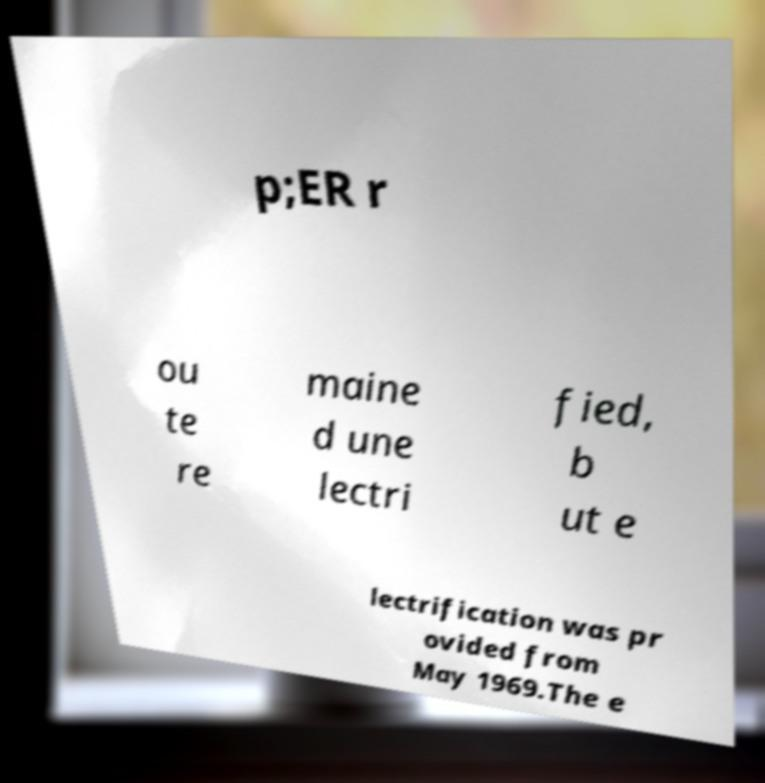I need the written content from this picture converted into text. Can you do that? p;ER r ou te re maine d une lectri fied, b ut e lectrification was pr ovided from May 1969.The e 